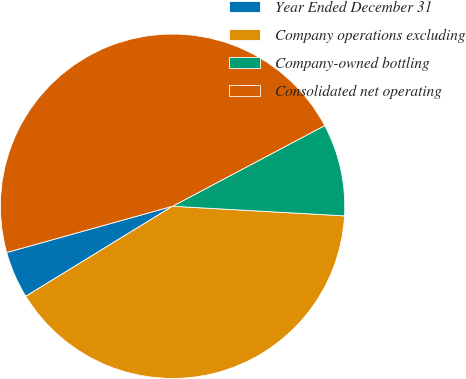Convert chart to OTSL. <chart><loc_0><loc_0><loc_500><loc_500><pie_chart><fcel>Year Ended December 31<fcel>Company operations excluding<fcel>Company-owned bottling<fcel>Consolidated net operating<nl><fcel>4.43%<fcel>40.35%<fcel>8.65%<fcel>46.57%<nl></chart> 